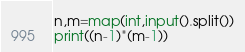Convert code to text. <code><loc_0><loc_0><loc_500><loc_500><_Python_>n,m=map(int,input().split())
print((n-1)*(m-1))</code> 